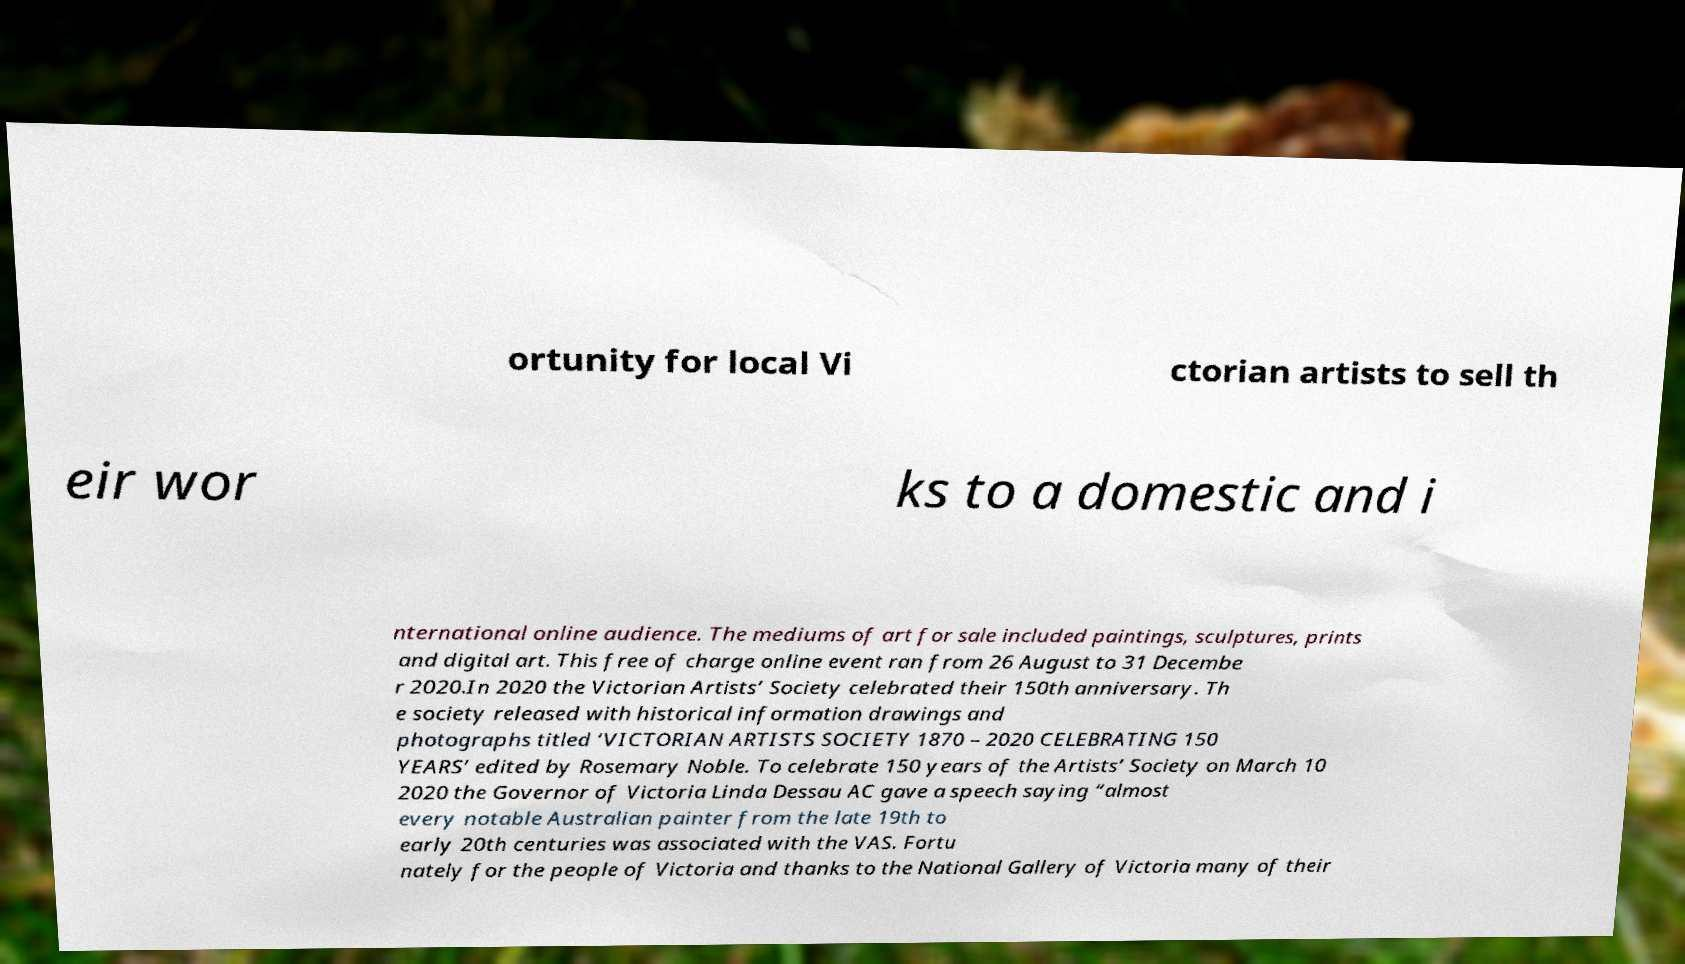Could you extract and type out the text from this image? ortunity for local Vi ctorian artists to sell th eir wor ks to a domestic and i nternational online audience. The mediums of art for sale included paintings, sculptures, prints and digital art. This free of charge online event ran from 26 August to 31 Decembe r 2020.In 2020 the Victorian Artists’ Society celebrated their 150th anniversary. Th e society released with historical information drawings and photographs titled ‘VICTORIAN ARTISTS SOCIETY 1870 – 2020 CELEBRATING 150 YEARS’ edited by Rosemary Noble. To celebrate 150 years of the Artists’ Society on March 10 2020 the Governor of Victoria Linda Dessau AC gave a speech saying “almost every notable Australian painter from the late 19th to early 20th centuries was associated with the VAS. Fortu nately for the people of Victoria and thanks to the National Gallery of Victoria many of their 